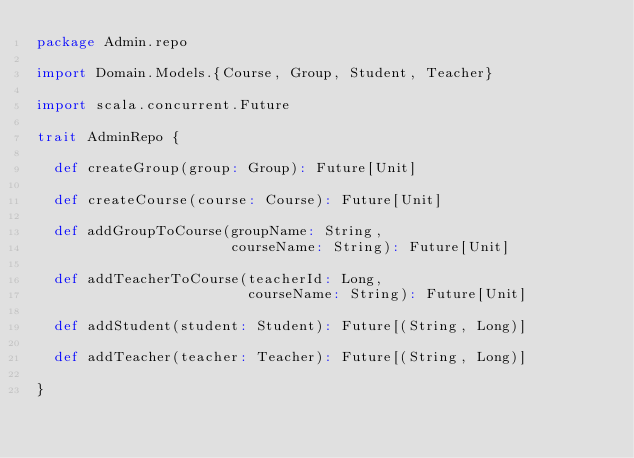Convert code to text. <code><loc_0><loc_0><loc_500><loc_500><_Scala_>package Admin.repo

import Domain.Models.{Course, Group, Student, Teacher}

import scala.concurrent.Future

trait AdminRepo {

  def createGroup(group: Group): Future[Unit]

  def createCourse(course: Course): Future[Unit]

  def addGroupToCourse(groupName: String,
                       courseName: String): Future[Unit]

  def addTeacherToCourse(teacherId: Long,
                         courseName: String): Future[Unit]

  def addStudent(student: Student): Future[(String, Long)]

  def addTeacher(teacher: Teacher): Future[(String, Long)]

}
</code> 